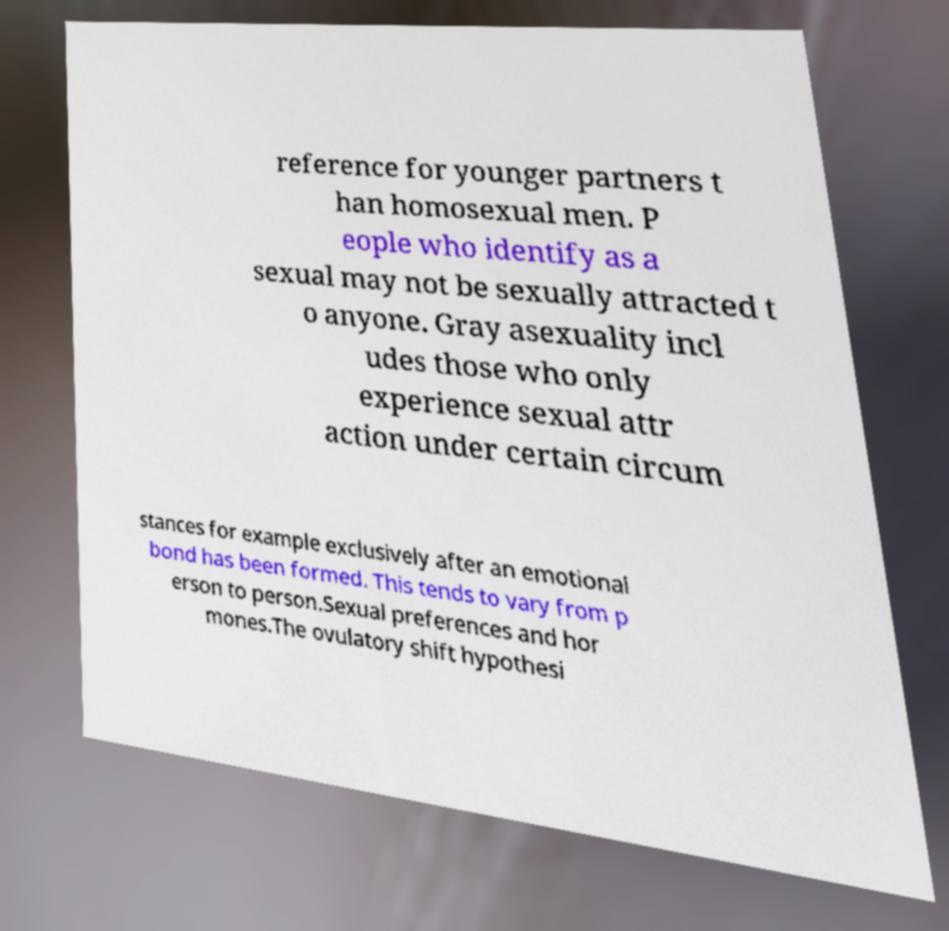I need the written content from this picture converted into text. Can you do that? reference for younger partners t han homosexual men. P eople who identify as a sexual may not be sexually attracted t o anyone. Gray asexuality incl udes those who only experience sexual attr action under certain circum stances for example exclusively after an emotional bond has been formed. This tends to vary from p erson to person.Sexual preferences and hor mones.The ovulatory shift hypothesi 